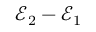Convert formula to latex. <formula><loc_0><loc_0><loc_500><loc_500>{ \mathcal { E } } _ { 2 } - { \mathcal { E } } _ { 1 }</formula> 